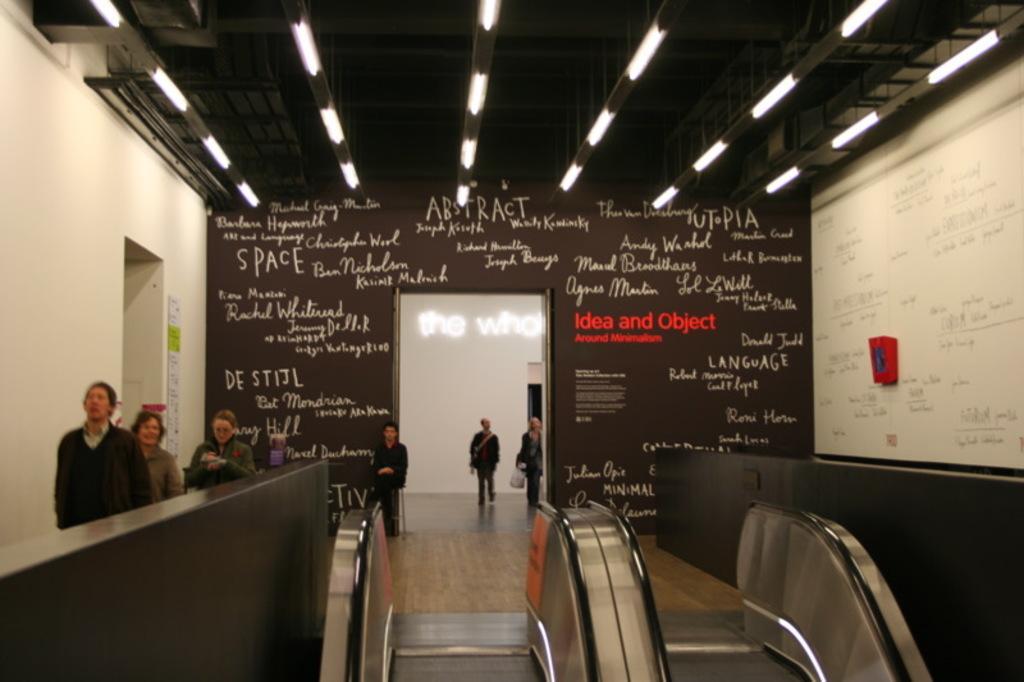In one or two sentences, can you explain what this image depicts? In this image in front there is a escalator. There are people walking on the floor. In the background of the image there is a wall with some text on it. On top of the image there are lights. There is a door. 